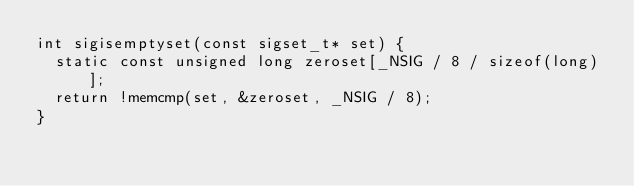Convert code to text. <code><loc_0><loc_0><loc_500><loc_500><_C_>int sigisemptyset(const sigset_t* set) {
  static const unsigned long zeroset[_NSIG / 8 / sizeof(long)];
  return !memcmp(set, &zeroset, _NSIG / 8);
}
</code> 